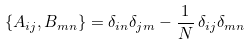<formula> <loc_0><loc_0><loc_500><loc_500>\{ A _ { i j } , B _ { m n } \} = \delta _ { i n } \delta _ { j m } - \frac { 1 } { N } \, \delta _ { i j } \delta _ { m n } \\</formula> 